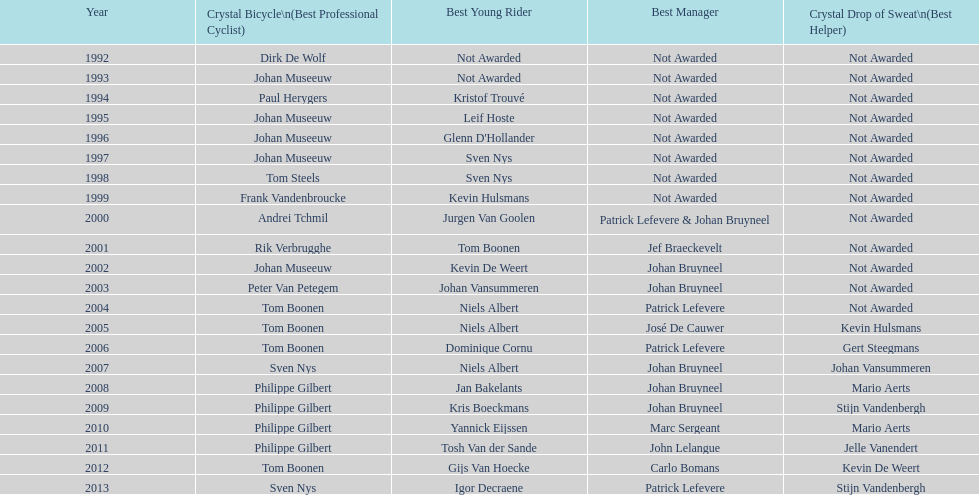Help me parse the entirety of this table. {'header': ['Year', 'Crystal Bicycle\\n(Best Professional Cyclist)', 'Best Young Rider', 'Best Manager', 'Crystal Drop of Sweat\\n(Best Helper)'], 'rows': [['1992', 'Dirk De Wolf', 'Not Awarded', 'Not Awarded', 'Not Awarded'], ['1993', 'Johan Museeuw', 'Not Awarded', 'Not Awarded', 'Not Awarded'], ['1994', 'Paul Herygers', 'Kristof Trouvé', 'Not Awarded', 'Not Awarded'], ['1995', 'Johan Museeuw', 'Leif Hoste', 'Not Awarded', 'Not Awarded'], ['1996', 'Johan Museeuw', "Glenn D'Hollander", 'Not Awarded', 'Not Awarded'], ['1997', 'Johan Museeuw', 'Sven Nys', 'Not Awarded', 'Not Awarded'], ['1998', 'Tom Steels', 'Sven Nys', 'Not Awarded', 'Not Awarded'], ['1999', 'Frank Vandenbroucke', 'Kevin Hulsmans', 'Not Awarded', 'Not Awarded'], ['2000', 'Andrei Tchmil', 'Jurgen Van Goolen', 'Patrick Lefevere & Johan Bruyneel', 'Not Awarded'], ['2001', 'Rik Verbrugghe', 'Tom Boonen', 'Jef Braeckevelt', 'Not Awarded'], ['2002', 'Johan Museeuw', 'Kevin De Weert', 'Johan Bruyneel', 'Not Awarded'], ['2003', 'Peter Van Petegem', 'Johan Vansummeren', 'Johan Bruyneel', 'Not Awarded'], ['2004', 'Tom Boonen', 'Niels Albert', 'Patrick Lefevere', 'Not Awarded'], ['2005', 'Tom Boonen', 'Niels Albert', 'José De Cauwer', 'Kevin Hulsmans'], ['2006', 'Tom Boonen', 'Dominique Cornu', 'Patrick Lefevere', 'Gert Steegmans'], ['2007', 'Sven Nys', 'Niels Albert', 'Johan Bruyneel', 'Johan Vansummeren'], ['2008', 'Philippe Gilbert', 'Jan Bakelants', 'Johan Bruyneel', 'Mario Aerts'], ['2009', 'Philippe Gilbert', 'Kris Boeckmans', 'Johan Bruyneel', 'Stijn Vandenbergh'], ['2010', 'Philippe Gilbert', 'Yannick Eijssen', 'Marc Sergeant', 'Mario Aerts'], ['2011', 'Philippe Gilbert', 'Tosh Van der Sande', 'John Lelangue', 'Jelle Vanendert'], ['2012', 'Tom Boonen', 'Gijs Van Hoecke', 'Carlo Bomans', 'Kevin De Weert'], ['2013', 'Sven Nys', 'Igor Decraene', 'Patrick Lefevere', 'Stijn Vandenbergh']]} Who has won the most best young rider awards? Niels Albert. 